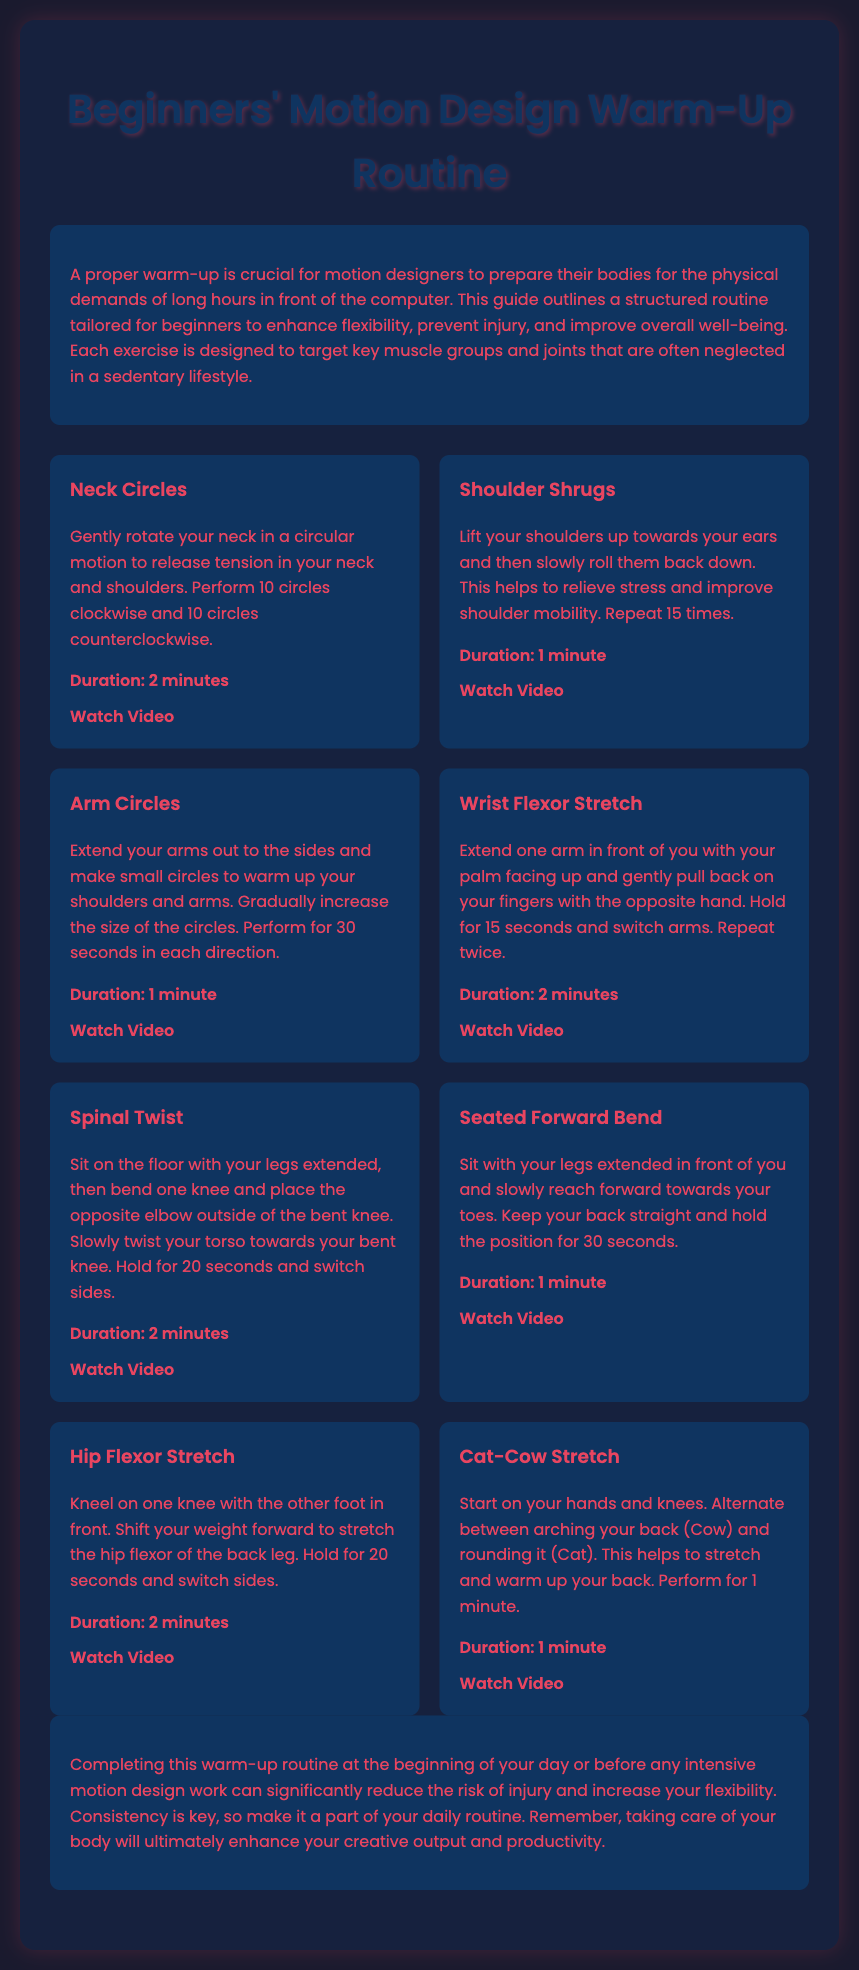What is the title of the workout plan? The title is prominently displayed at the top of the document.
Answer: Beginners' Motion Design Warm-Up Routine How many exercises are included in the routine? The document lists each exercise in a structured format, making it easy to count.
Answer: 8 What is the duration of the Neck Circles exercise? Each exercise has a specified duration mentioned below its description.
Answer: 2 minutes Which stretch is performed to target the hip flexors? The document names the exercises that address specific muscle groups.
Answer: Hip Flexor Stretch How many circles are performed during the Arm Circles exercise? The instruction for this exercise details the number of circles to perform.
Answer: 30 seconds in each direction What is the purpose of the warm-up routine? The introduction outlines the benefits of completing this routine.
Answer: Flexibility and Injury Prevention How long should the Seated Forward Bend be held? The document states the duration for holding this specific stretch.
Answer: 30 seconds What exercise helps to relieve tension in the neck and shoulders? The exercises listed provide specific purposes for each movement.
Answer: Neck Circles At what point in your day should you complete this warm-up routine? The conclusion provides recommendations on when to perform the routine.
Answer: Beginning of your day or before any intensive motion design work 